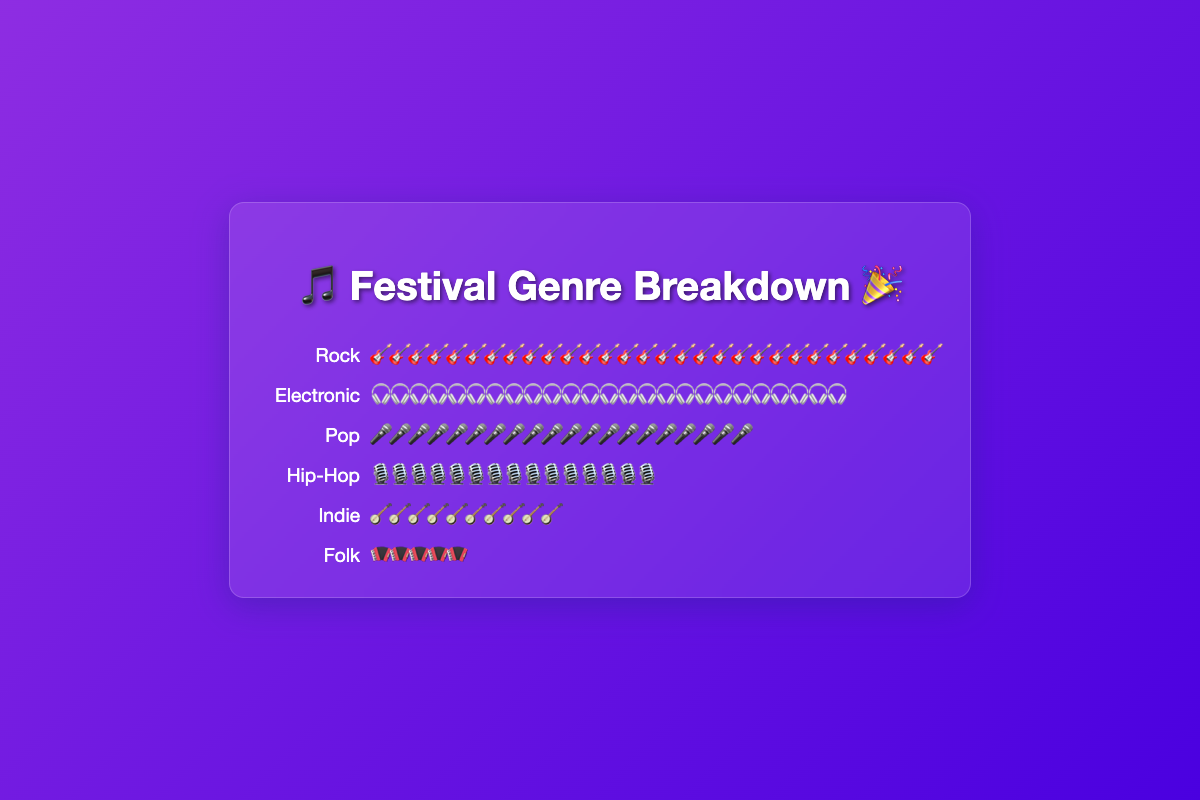Which music genre has the highest count of festival-goers? Rock has the highest count of festival-goers represented by the largest number of guitar icons.
Answer: Rock How many symbols represent the Pop genre? There are 20 microphone icons representing the Pop genre.
Answer: 20 What is the sum of festival-goers for Electronic and Hip-Hop genres? Electronic has 25 and Hip-Hop has 15, so the sum is 25 + 15 = 40.
Answer: 40 Which genre has fewer festival-goers, Indie or Folk? Folk has 5 while Indie has 10 festival-goers, so Folk has fewer festival-goers.
Answer: Folk By how much does the count of Rock festival-goers exceed that of Pop festival-goers? Rock has 30 and Pop has 20, so the excess is 30 - 20 = 10.
Answer: 10 Which two genres have the closest number of festival-goers? Pop has 20 and Hip-Hop has 15, with a difference of just 5.
Answer: Pop and Hip-Hop What is the total count of festival-goers represented in the plot? Adding counts of all genres: 30 (Rock) + 25 (Electronic) + 20 (Pop) + 15 (Hip-Hop) + 10 (Indie) + 5 (Folk) = 105.
Answer: 105 Rank the genres from most preferred to least preferred based on the number of festival-goers. The genres ranked from most preferred to least preferred are: Rock (30), Electronic (25), Pop (20), Hip-Hop (15), Indie (10), and Folk (5).
Answer: Rock, Electronic, Pop, Hip-Hop, Indie, Folk How many more festival-goers are there for Indie compared to Folk? Indie has 10 and Folk has 5, so Indie has 10 - 5 = 5 more festival-goers than Folk.
Answer: 5 If a new genre is added with a count equal to the average of the current genres' counts, what would that count be? The total count of all genres is 105, and there are 6 genres. The average is 105 / 6 = 17.5.
Answer: 17.5 